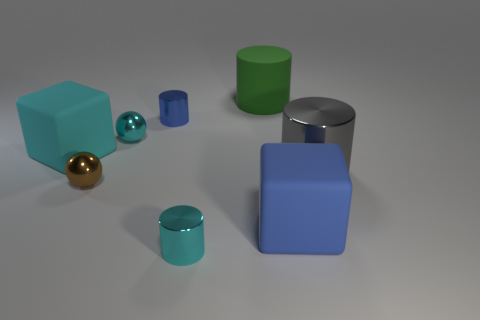Subtract 1 cylinders. How many cylinders are left? 3 Add 2 small cyan things. How many objects exist? 10 Subtract all blocks. How many objects are left? 6 Subtract all small purple rubber cylinders. Subtract all blue objects. How many objects are left? 6 Add 4 cyan metallic cylinders. How many cyan metallic cylinders are left? 5 Add 1 small blue cylinders. How many small blue cylinders exist? 2 Subtract 0 gray spheres. How many objects are left? 8 